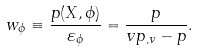Convert formula to latex. <formula><loc_0><loc_0><loc_500><loc_500>w _ { \phi } \equiv \frac { p ( X , \phi ) } { \varepsilon _ { \phi } } = \frac { p } { v p _ { , v } - p } .</formula> 